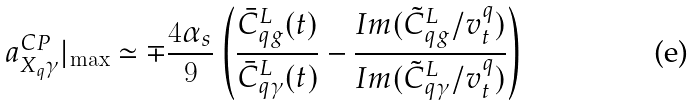<formula> <loc_0><loc_0><loc_500><loc_500>a _ { X _ { q } \gamma } ^ { C P } | _ { \max } \simeq \mp \frac { 4 \alpha _ { s } } { 9 } \left ( \frac { \bar { C } _ { q g } ^ { L } ( t ) } { \bar { C } _ { q \gamma } ^ { L } ( t ) } - \frac { I m ( \tilde { C } _ { q g } ^ { L } / v _ { t } ^ { q } ) } { I m ( \tilde { C } _ { q \gamma } ^ { L } / v _ { t } ^ { q } ) } \right )</formula> 